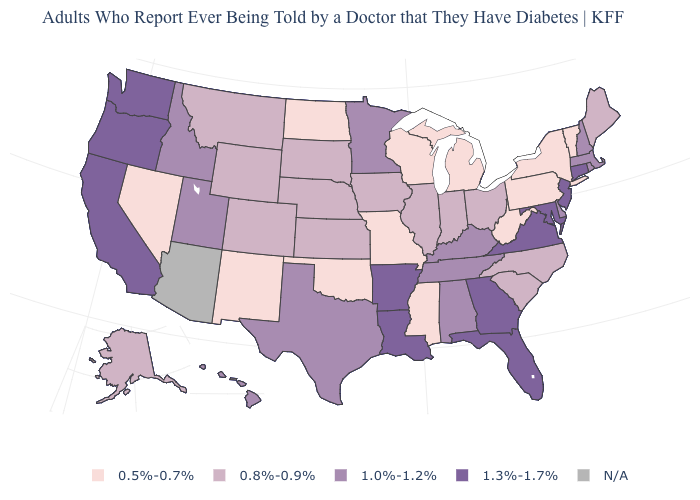Does Florida have the highest value in the USA?
Short answer required. Yes. Name the states that have a value in the range 0.8%-0.9%?
Answer briefly. Alaska, Colorado, Illinois, Indiana, Iowa, Kansas, Maine, Montana, Nebraska, North Carolina, Ohio, South Carolina, South Dakota, Wyoming. Among the states that border Rhode Island , which have the highest value?
Short answer required. Connecticut. Does Missouri have the lowest value in the MidWest?
Write a very short answer. Yes. Among the states that border Nebraska , does Missouri have the lowest value?
Quick response, please. Yes. Among the states that border West Virginia , which have the lowest value?
Concise answer only. Pennsylvania. Name the states that have a value in the range 1.3%-1.7%?
Short answer required. Arkansas, California, Connecticut, Florida, Georgia, Louisiana, Maryland, New Jersey, Oregon, Virginia, Washington. Does the map have missing data?
Concise answer only. Yes. Does California have the highest value in the West?
Quick response, please. Yes. Does Nevada have the lowest value in the West?
Be succinct. Yes. What is the highest value in the USA?
Be succinct. 1.3%-1.7%. Among the states that border New Mexico , does Texas have the lowest value?
Short answer required. No. Name the states that have a value in the range N/A?
Give a very brief answer. Arizona. Name the states that have a value in the range 0.8%-0.9%?
Write a very short answer. Alaska, Colorado, Illinois, Indiana, Iowa, Kansas, Maine, Montana, Nebraska, North Carolina, Ohio, South Carolina, South Dakota, Wyoming. Does the map have missing data?
Write a very short answer. Yes. 